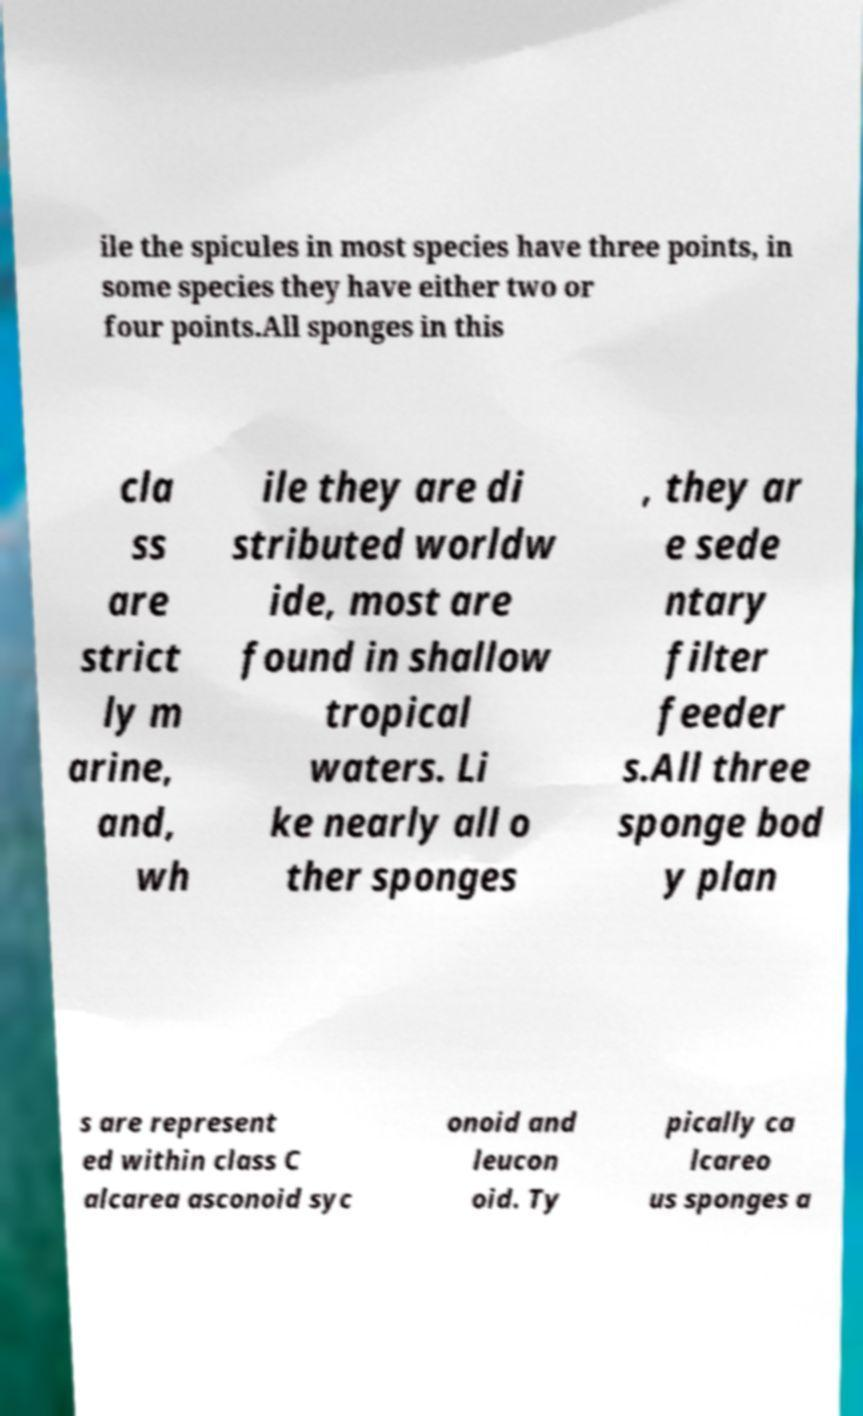Please identify and transcribe the text found in this image. ile the spicules in most species have three points, in some species they have either two or four points.All sponges in this cla ss are strict ly m arine, and, wh ile they are di stributed worldw ide, most are found in shallow tropical waters. Li ke nearly all o ther sponges , they ar e sede ntary filter feeder s.All three sponge bod y plan s are represent ed within class C alcarea asconoid syc onoid and leucon oid. Ty pically ca lcareo us sponges a 